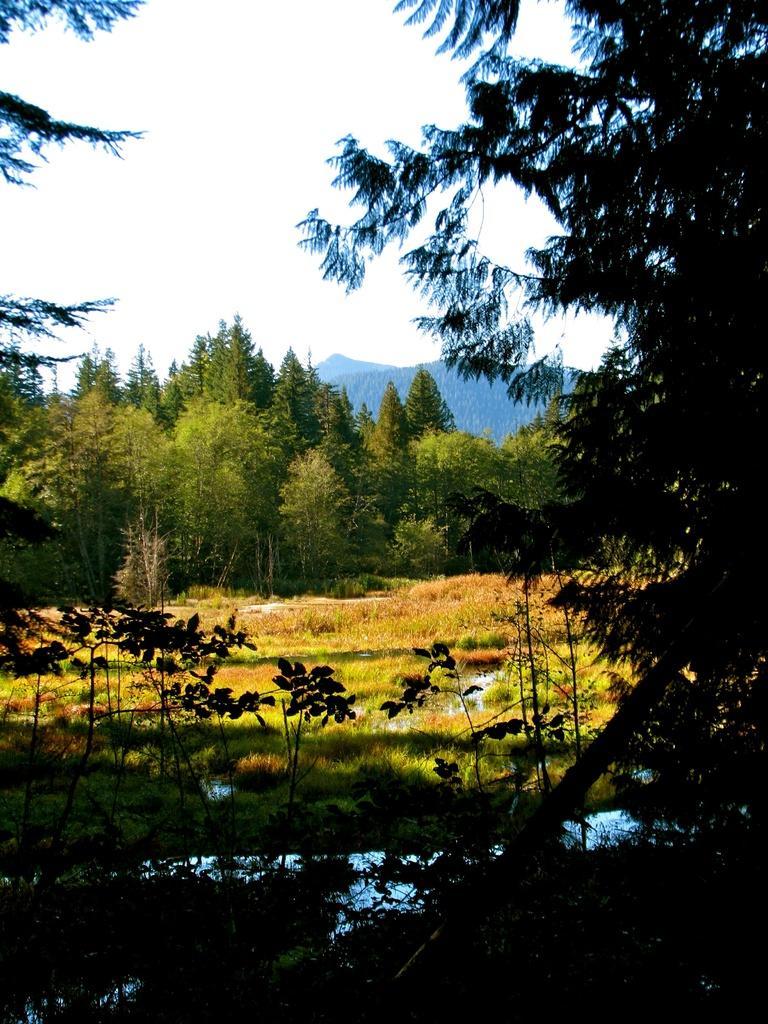Please provide a concise description of this image. This image is taken outdoors. At the bottom of the image there are a few plants. In the middle of the image there is a ground with grass and a few plants on it. In the background there are many trees and there are a few hills. 